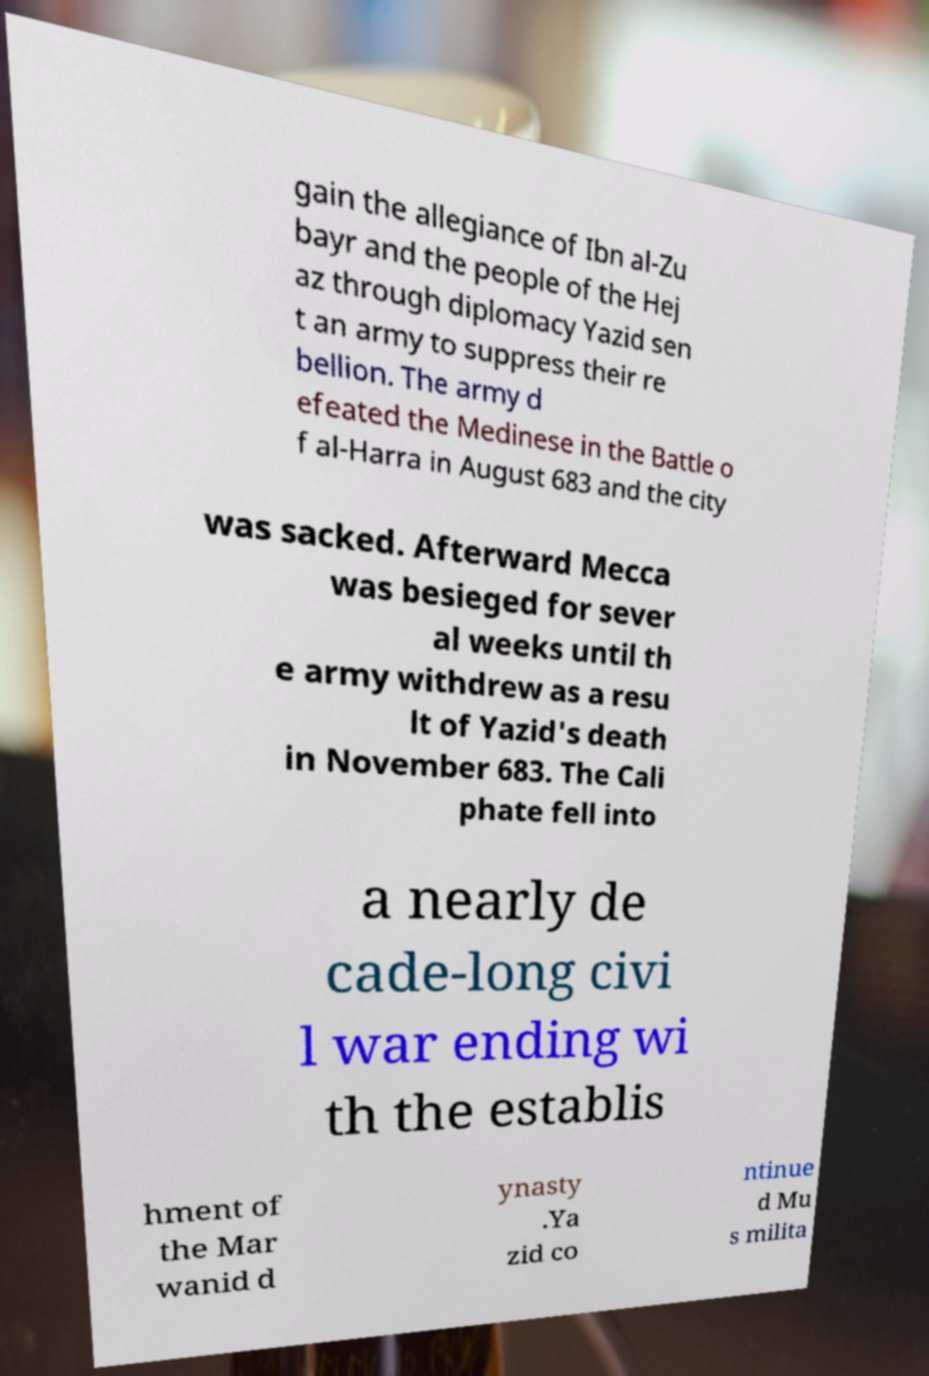Can you read and provide the text displayed in the image?This photo seems to have some interesting text. Can you extract and type it out for me? gain the allegiance of Ibn al-Zu bayr and the people of the Hej az through diplomacy Yazid sen t an army to suppress their re bellion. The army d efeated the Medinese in the Battle o f al-Harra in August 683 and the city was sacked. Afterward Mecca was besieged for sever al weeks until th e army withdrew as a resu lt of Yazid's death in November 683. The Cali phate fell into a nearly de cade-long civi l war ending wi th the establis hment of the Mar wanid d ynasty .Ya zid co ntinue d Mu s milita 